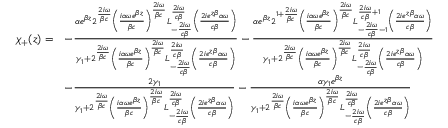Convert formula to latex. <formula><loc_0><loc_0><loc_500><loc_500>\begin{array} { r l } { \chi _ { + } ( z ) = } & { - \frac { \alpha e ^ { \beta z } 2 ^ { \frac { 2 i \omega } { \beta c } } \left ( \frac { i \alpha \omega e ^ { \beta z } } { \beta c } \right ) ^ { \frac { 2 i \omega } { \beta c } } L _ { - \frac { 2 i \omega } { c \beta } } ^ { \frac { 2 i \omega } { c \beta } } \left ( \frac { 2 i e ^ { z \beta } \alpha \omega } { c \beta } \right ) } { \gamma _ { 1 } + 2 ^ { \frac { 2 i \omega } { \beta c } } \left ( \frac { i \alpha \omega e ^ { \beta z } } { \beta c } \right ) ^ { \frac { 2 i \omega } { \beta c } } L _ { - \frac { 2 i \omega } { c \beta } } ^ { \frac { 2 i \omega } { c \beta } } \left ( \frac { 2 i e ^ { z \beta } \alpha \omega } { c \beta } \right ) } - \frac { \alpha e ^ { \beta z } 2 ^ { 1 + \frac { 2 i \omega } { \beta c } } \left ( \frac { i \alpha \omega e ^ { \beta z } } { \beta c } \right ) ^ { \frac { 2 i \omega } { \beta c } } L _ { - \frac { 2 i \omega } { c \beta } - 1 } ^ { \frac { 2 i \omega } { c \beta } + 1 } \left ( \frac { 2 i e ^ { z \beta } \alpha \omega } { c \beta } \right ) } { \gamma _ { 1 } + 2 ^ { \frac { 2 i \omega } { \beta c } } \left ( \frac { i \alpha \omega e ^ { \beta z } } { \beta c } \right ) ^ { \frac { 2 i \omega } { \beta c } } L _ { - \frac { 2 i \omega } { c \beta } } ^ { \frac { 2 i \omega } { c \beta } } \left ( \frac { 2 i e ^ { z \beta } \alpha \omega } { c \beta } \right ) } } \\ & { - \frac { 2 \gamma _ { 1 } } { \gamma _ { 1 } + 2 ^ { \frac { 2 i \omega } { \beta c } } \left ( \frac { i \alpha \omega e ^ { \beta z } } { \beta c } \right ) ^ { \frac { 2 i \omega } { \beta c } } L _ { - \frac { 2 i \omega } { c \beta } } ^ { \frac { 2 i \omega } { c \beta } } \left ( \frac { 2 i e ^ { z \beta } \alpha \omega } { c \beta } \right ) } - \frac { \alpha \gamma _ { 1 } e ^ { \beta z } } { \gamma _ { 1 } + 2 ^ { \frac { 2 i \omega } { \beta c } } \left ( \frac { i \alpha \omega e ^ { \beta z } } { \beta c } \right ) ^ { \frac { 2 i \omega } { \beta c } } L _ { - \frac { 2 i \omega } { c \beta } } ^ { \frac { 2 i \omega } { c \beta } } \left ( \frac { 2 i e ^ { z \beta } \alpha \omega } { c \beta } \right ) } } \end{array}</formula> 